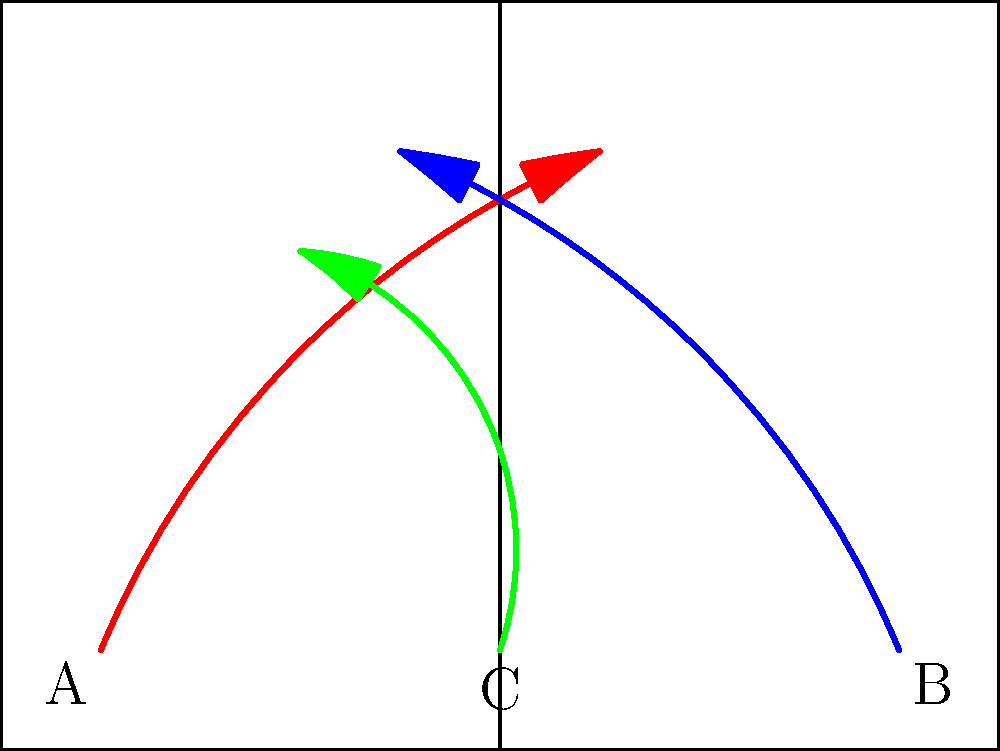Based on the trajectory map shown, which player's movement pattern is most likely to create space for a potential shot attempt near the top of the key? To answer this question, we need to analyze the movement patterns of all three players (A, B, and C) and their potential impact on creating space for a shot attempt near the top of the key. Let's break down the analysis step-by-step:

1. Player A (red trajectory):
   - Starts from the left corner
   - Moves towards the center of the court
   - Ends up near the top of the key

2. Player B (blue trajectory):
   - Starts from the right corner
   - Moves towards the center of the court
   - Ends up on the left side of the court, above the free-throw line

3. Player C (green trajectory):
   - Starts from the middle of the baseline
   - Moves straight up the court
   - Curves towards the left side, ending up near the left elbow

Analyzing the impact of each player's movement:

1. Player A's movement draws defenders from the left side of the court towards the top of the key, potentially creating space in the left corner or wing.

2. Player B's movement pulls defenders from the right side of the court towards the left, potentially opening up space on the right side or in the paint.

3. Player C's movement is the most likely to create space for a shot attempt near the top of the key because:
   - It starts in the middle, drawing attention from interior defenders
   - The initial straight-line movement suggests a potential screen or decoy action
   - The curve towards the left elbow can draw defenders away from the top of the key

Player C's movement pattern is the most effective in creating space near the top of the key because it combines a central starting position, a potential screening action, and a movement that draws defenders away from the target area.
Answer: Player C 